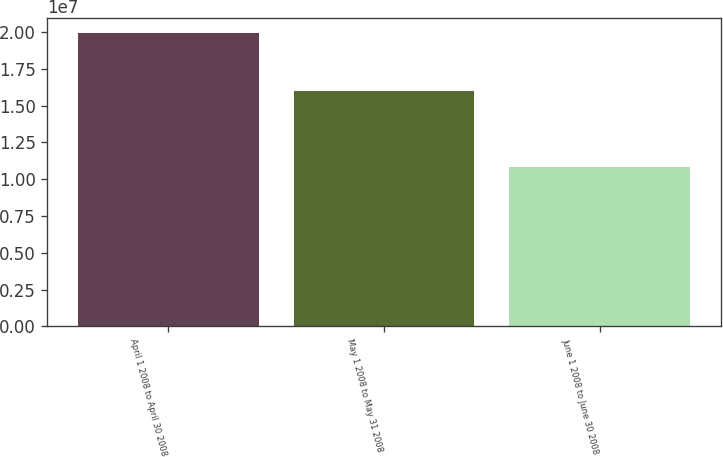Convert chart to OTSL. <chart><loc_0><loc_0><loc_500><loc_500><bar_chart><fcel>April 1 2008 to April 30 2008<fcel>May 1 2008 to May 31 2008<fcel>June 1 2008 to June 30 2008<nl><fcel>1.99307e+07<fcel>1.59747e+07<fcel>1.08439e+07<nl></chart> 